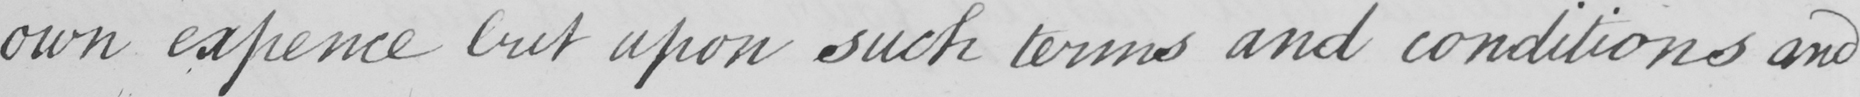What text is written in this handwritten line? own expence but upon such terms and conditions and 